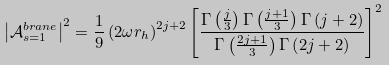<formula> <loc_0><loc_0><loc_500><loc_500>\left | \mathcal { A } _ { s = 1 } ^ { b r a n e } \right | ^ { 2 } = \frac { 1 } { 9 } \left ( 2 \omega r _ { h } \right ) ^ { 2 j + 2 } \left [ \frac { \Gamma \left ( \frac { j } { 3 } \right ) \Gamma \left ( \frac { j + 1 } { 3 } \right ) \Gamma \left ( j + 2 \right ) } { \Gamma \left ( \frac { 2 j + 1 } { 3 } \right ) \Gamma \left ( 2 j + 2 \right ) } \right ] ^ { 2 }</formula> 